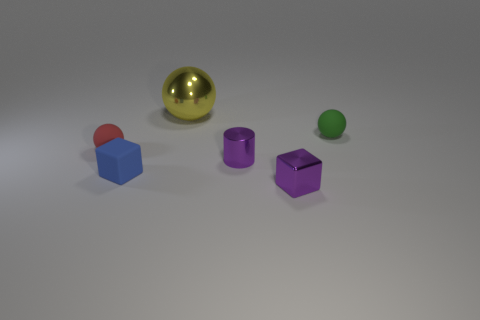There is a tiny matte object on the left side of the small blue rubber cube; what shape is it?
Ensure brevity in your answer.  Sphere. There is a metal cube that is the same color as the tiny cylinder; what is its size?
Keep it short and to the point. Small. Is there a blue block of the same size as the yellow metallic thing?
Provide a succinct answer. No. Is the object that is behind the green object made of the same material as the purple cylinder?
Offer a terse response. Yes. Are there the same number of small red spheres behind the blue block and purple metal blocks that are on the left side of the small red ball?
Provide a short and direct response. No. There is a shiny object that is both right of the yellow shiny object and behind the rubber cube; what is its shape?
Offer a terse response. Cylinder. What number of metallic cylinders are in front of the purple cube?
Make the answer very short. 0. How many other objects are there of the same shape as the large shiny object?
Your answer should be very brief. 2. Is the number of tiny purple cylinders less than the number of small gray blocks?
Your response must be concise. No. There is a thing that is in front of the tiny cylinder and to the right of the small matte cube; how big is it?
Provide a short and direct response. Small. 